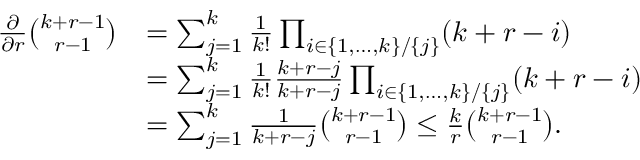<formula> <loc_0><loc_0><loc_500><loc_500>\begin{array} { r l } { \frac { \partial } { \partial r } \binom { k + r - 1 } { r - 1 } } & { = \sum _ { j = 1 } ^ { k } \frac { 1 } { k ! } \prod _ { i \in \{ 1 , \dots , k \} / \{ j \} } ( k + r - i ) } \\ & { = \sum _ { j = 1 } ^ { k } \frac { 1 } { k ! } \frac { k + r - j } { k + r - j } \prod _ { i \in \{ 1 , \dots , k \} / \{ j \} } ( k + r - i ) } \\ & { = \sum _ { j = 1 } ^ { k } \frac { 1 } { k + r - j } \binom { k + r - 1 } { r - 1 } \leq \frac { k } { r } \binom { k + r - 1 } { r - 1 } . } \end{array}</formula> 